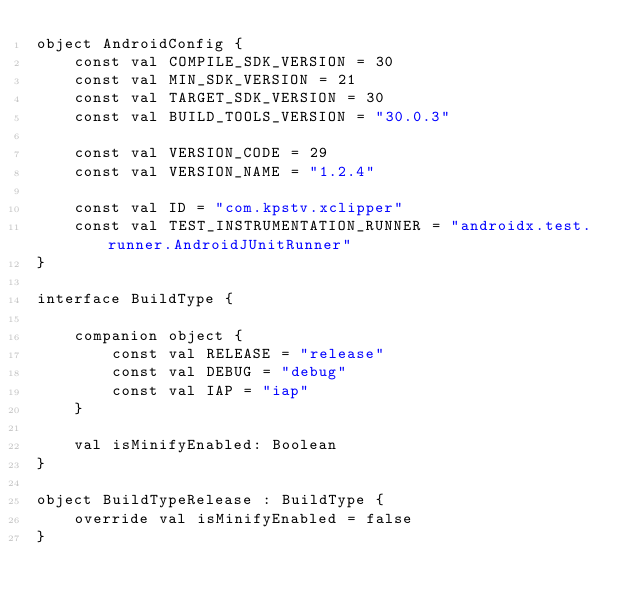Convert code to text. <code><loc_0><loc_0><loc_500><loc_500><_Kotlin_>object AndroidConfig {
    const val COMPILE_SDK_VERSION = 30
    const val MIN_SDK_VERSION = 21
    const val TARGET_SDK_VERSION = 30
    const val BUILD_TOOLS_VERSION = "30.0.3"

    const val VERSION_CODE = 29
    const val VERSION_NAME = "1.2.4"

    const val ID = "com.kpstv.xclipper"
    const val TEST_INSTRUMENTATION_RUNNER = "androidx.test.runner.AndroidJUnitRunner"
}

interface BuildType {

    companion object {
        const val RELEASE = "release"
        const val DEBUG = "debug"
        const val IAP = "iap"
    }

    val isMinifyEnabled: Boolean
}

object BuildTypeRelease : BuildType {
    override val isMinifyEnabled = false
}
</code> 